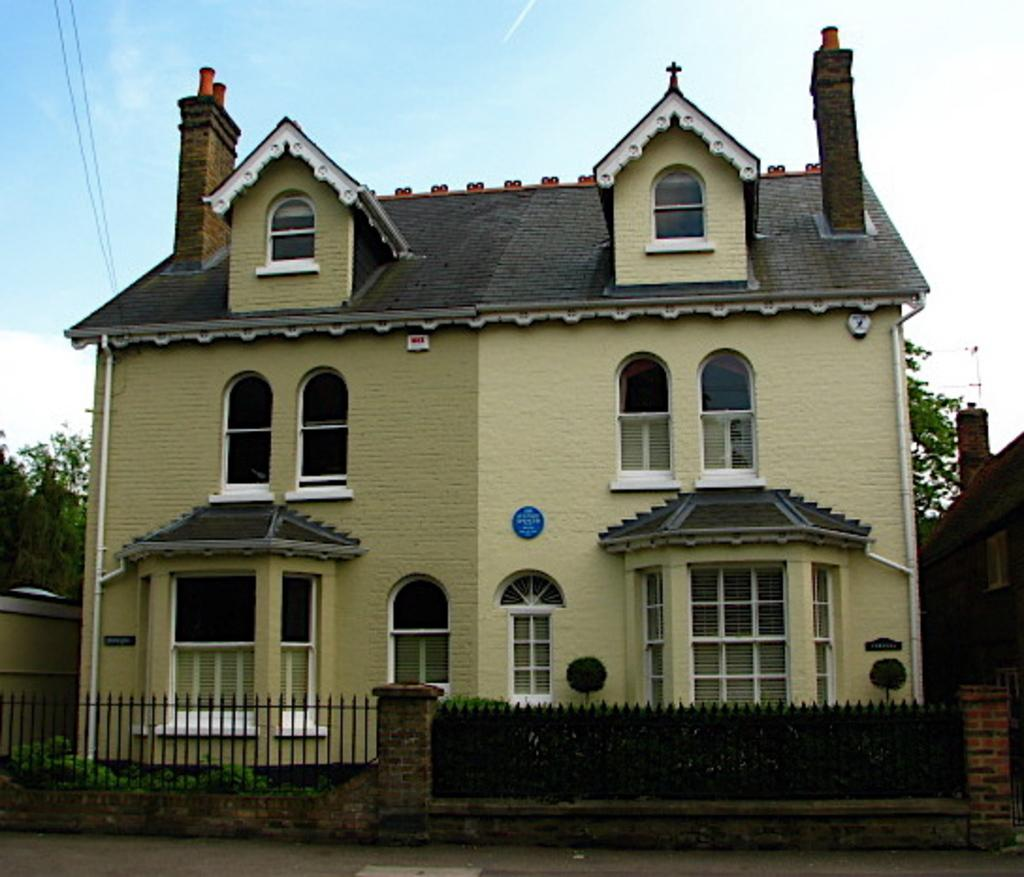What type of structure is present in the image? There is a building in the image. What can be seen running horizontally across the image? There is fencing from left to right in the image. What is visible in the background of the image? There are trees in the background of the image. What else can be seen in the image besides the building and fencing? There are wires visible in the image. How would you describe the sky in the image? The sky is blue and cloudy in the image. What flavor of ice cream is being served at the event in the image? There is no event or ice cream present in the image; it features a building, fencing, trees, wires, and a blue and cloudy sky. Can you hear the sound of a horn in the image? There is no sound or horn present in the image; it is a static visual representation. 